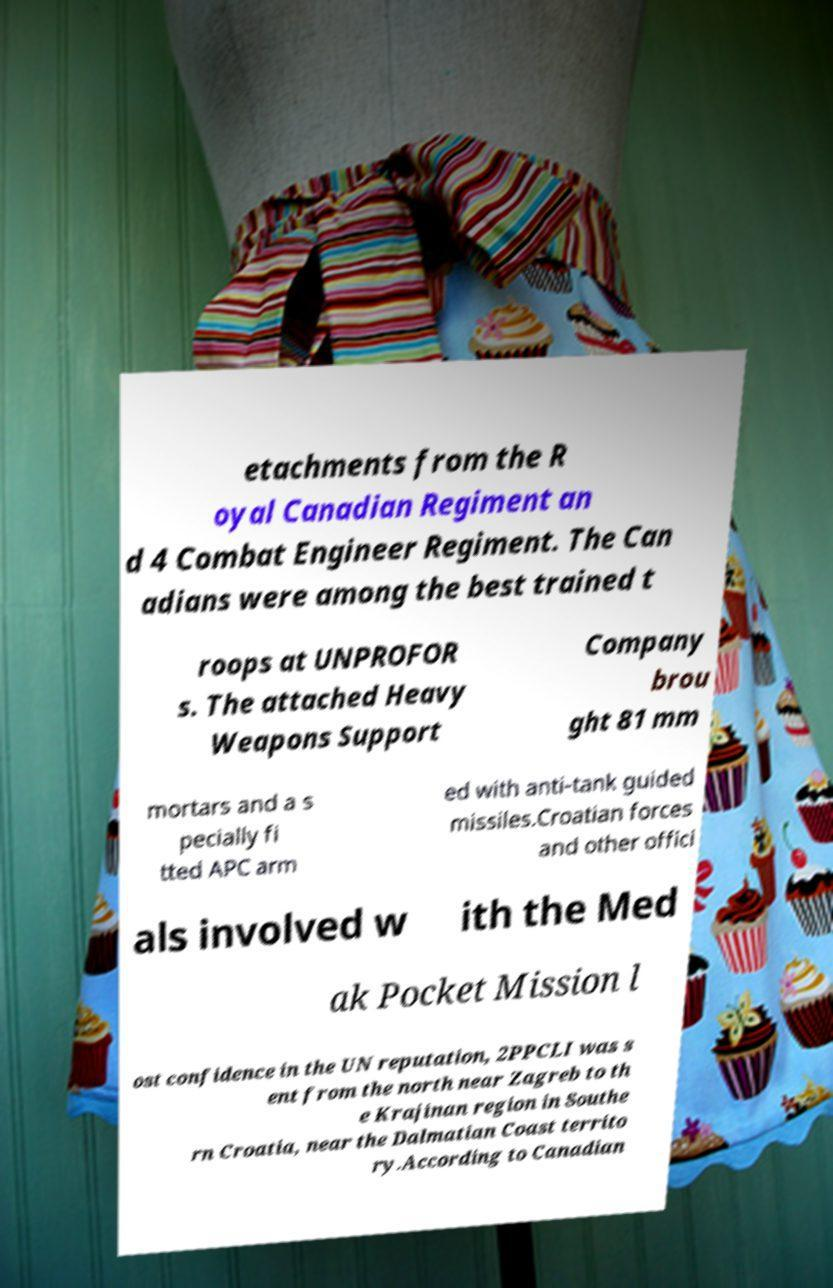Can you read and provide the text displayed in the image?This photo seems to have some interesting text. Can you extract and type it out for me? etachments from the R oyal Canadian Regiment an d 4 Combat Engineer Regiment. The Can adians were among the best trained t roops at UNPROFOR s. The attached Heavy Weapons Support Company brou ght 81 mm mortars and a s pecially fi tted APC arm ed with anti-tank guided missiles.Croatian forces and other offici als involved w ith the Med ak Pocket Mission l ost confidence in the UN reputation, 2PPCLI was s ent from the north near Zagreb to th e Krajinan region in Southe rn Croatia, near the Dalmatian Coast territo ry.According to Canadian 